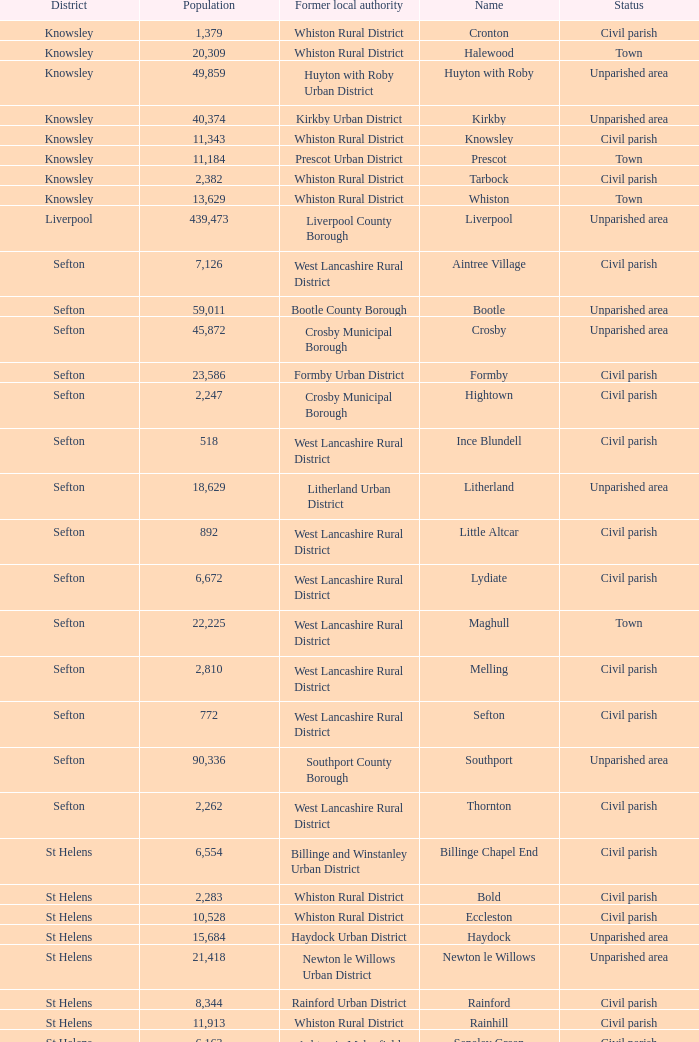What is the district of wallasey Wirral. 